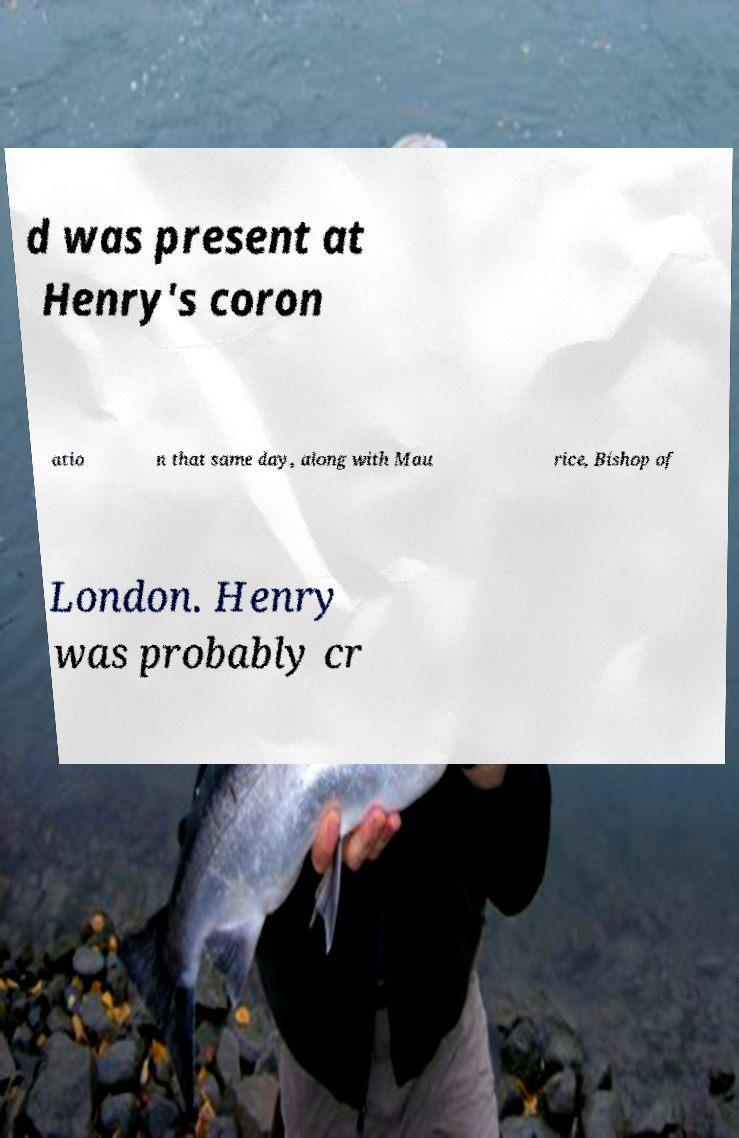Please identify and transcribe the text found in this image. d was present at Henry's coron atio n that same day, along with Mau rice, Bishop of London. Henry was probably cr 